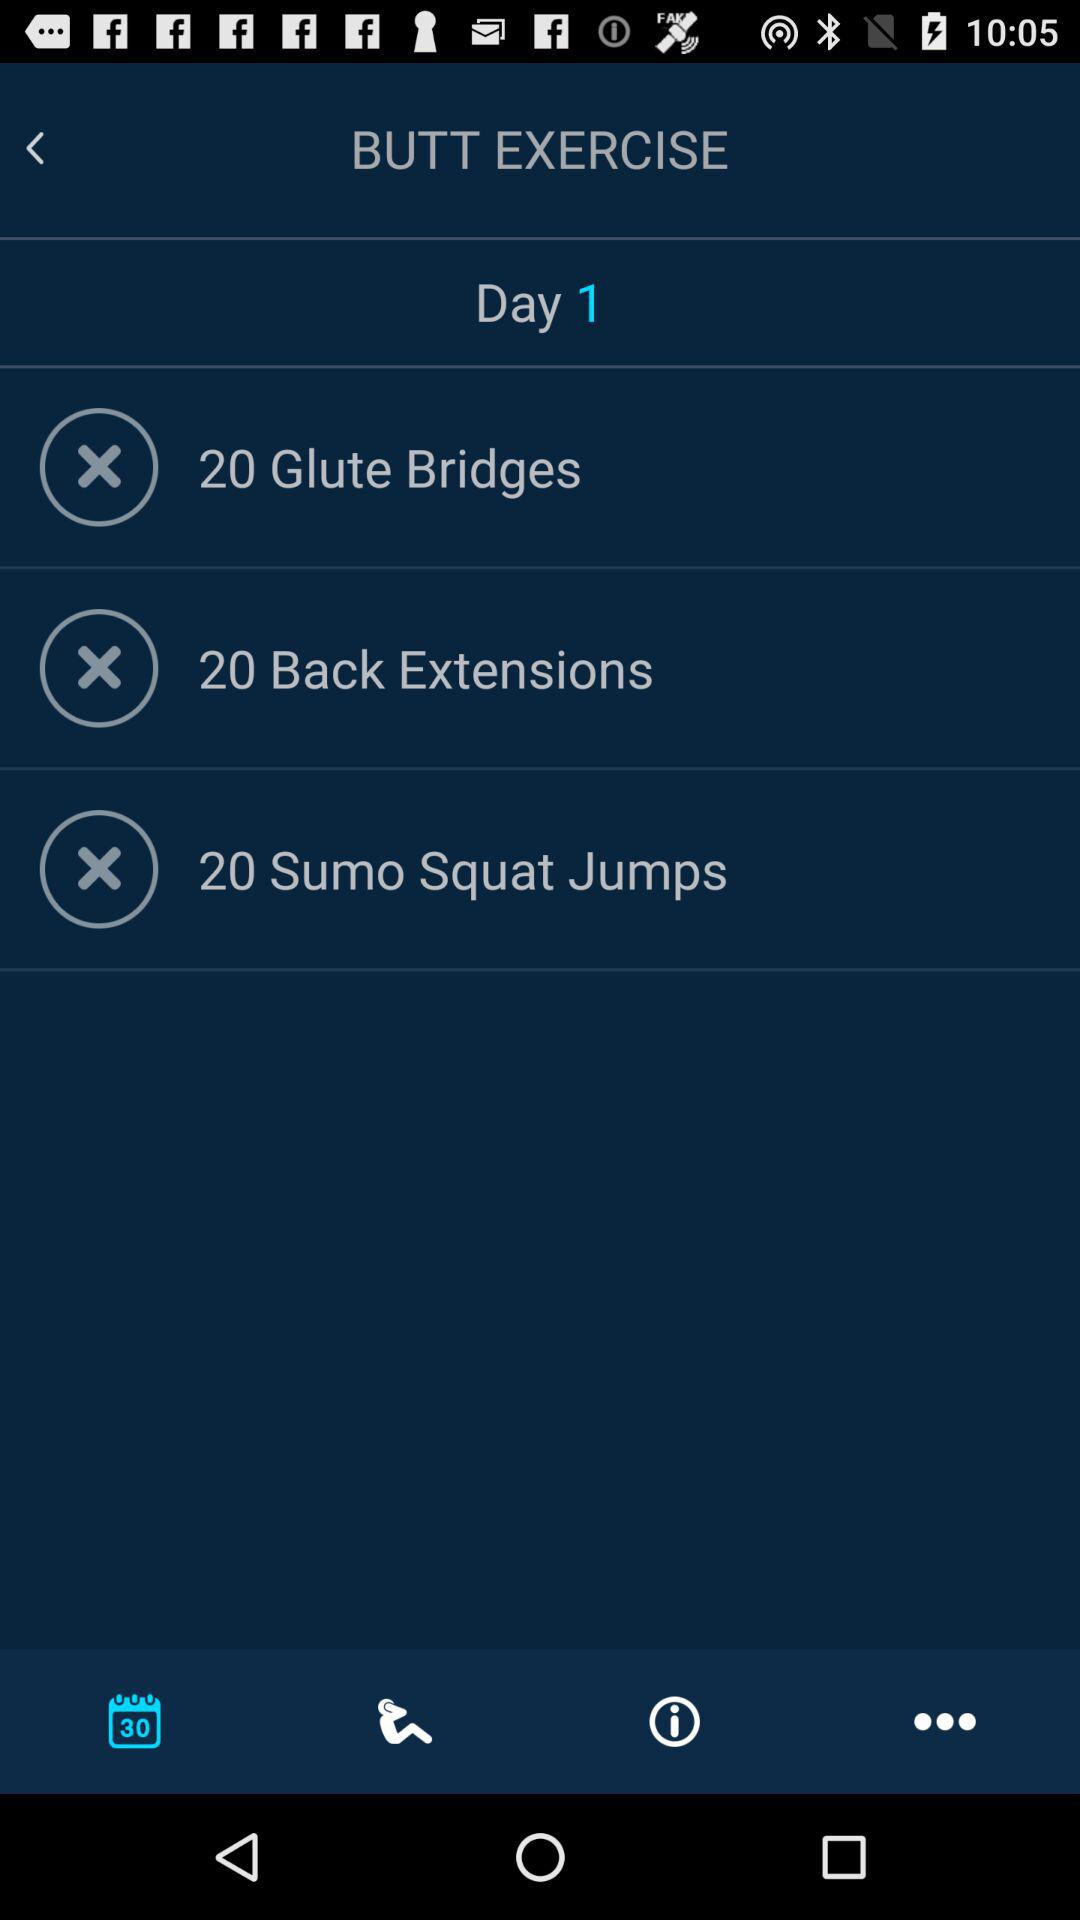What is the name of the exercise? The names of the exercises are glute bridges, back extensions, and sumo squat jumps. 